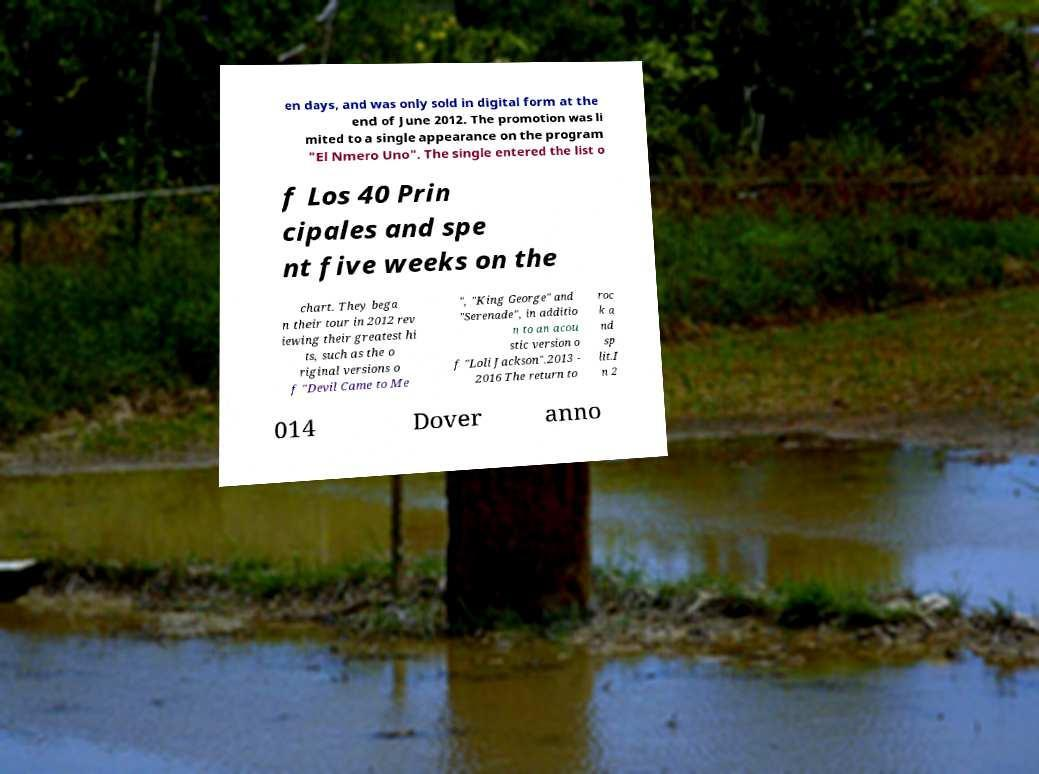Please identify and transcribe the text found in this image. en days, and was only sold in digital form at the end of June 2012. The promotion was li mited to a single appearance on the program "El Nmero Uno". The single entered the list o f Los 40 Prin cipales and spe nt five weeks on the chart. They bega n their tour in 2012 rev iewing their greatest hi ts, such as the o riginal versions o f "Devil Came to Me ", "King George" and "Serenade", in additio n to an acou stic version o f "Loli Jackson".2013 - 2016 The return to roc k a nd sp lit.I n 2 014 Dover anno 